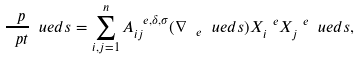Convert formula to latex. <formula><loc_0><loc_0><loc_500><loc_500>\frac { \ p } { \ p t } \ u e d s = \sum _ { i , j = 1 } ^ { n } A _ { i j } ^ { \ e , \delta , \sigma } ( \nabla _ { \ e } \ u e d s ) X _ { i } ^ { \ e } X _ { j } ^ { \ e } \ u e d s ,</formula> 